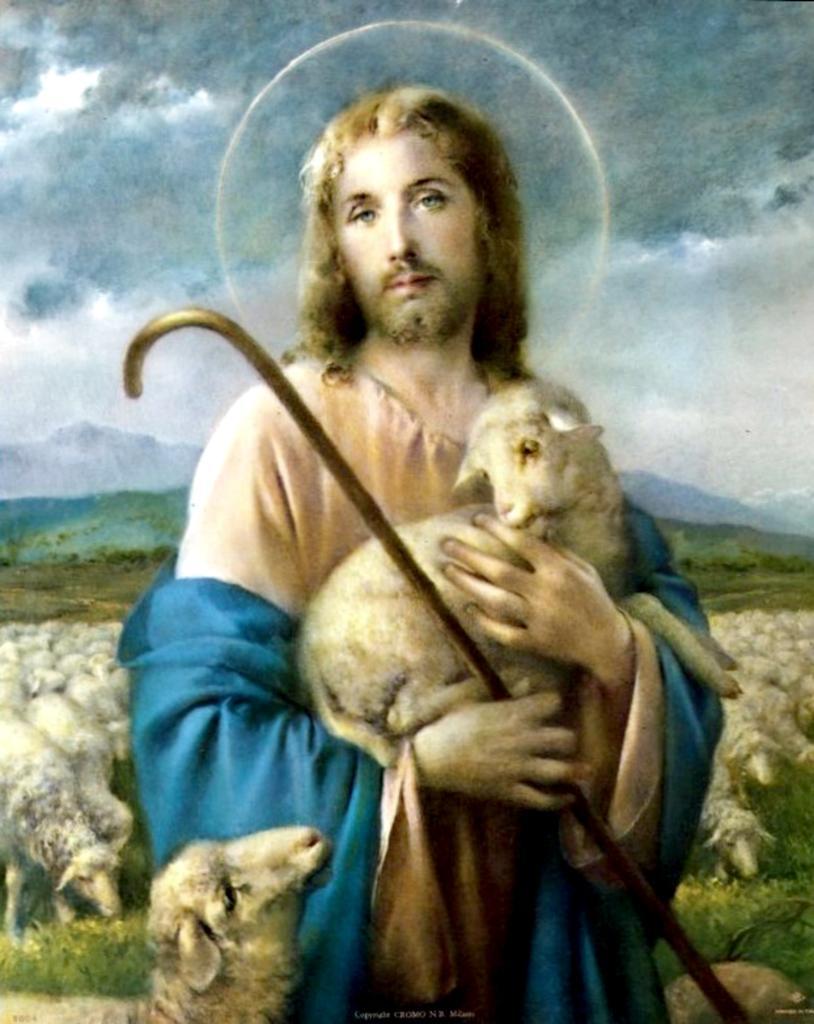Could you give a brief overview of what you see in this image? In this picture we can see a person holding a sheep and a wooden stick in his hands. Some grass is visible on the ground. We can see some greenery and mountains in the background. Sky is cloudy. 